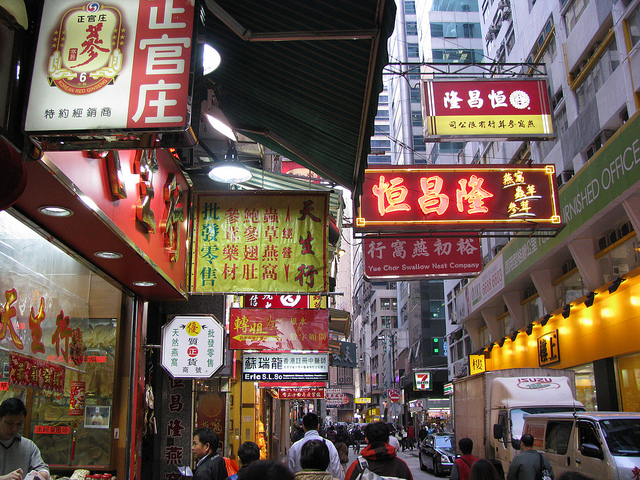Please transcribe the text in this image. OFFICE Erle 